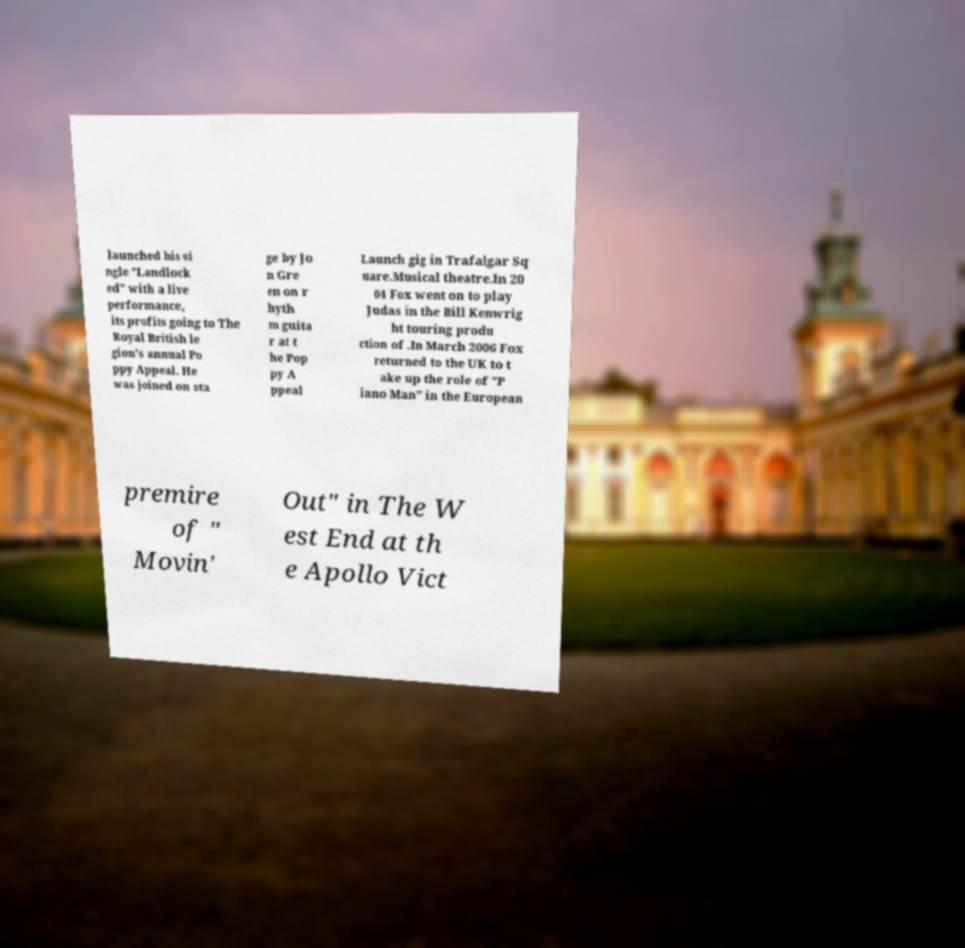What messages or text are displayed in this image? I need them in a readable, typed format. launched his si ngle "Landlock ed" with a live performance, its profits going to The Royal British le gion's annual Po ppy Appeal. He was joined on sta ge by Jo n Gre en on r hyth m guita r at t he Pop py A ppeal Launch gig in Trafalgar Sq uare.Musical theatre.In 20 04 Fox went on to play Judas in the Bill Kenwrig ht touring produ ction of .In March 2006 Fox returned to the UK to t ake up the role of "P iano Man" in the European premire of " Movin' Out" in The W est End at th e Apollo Vict 